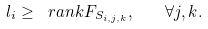Convert formula to latex. <formula><loc_0><loc_0><loc_500><loc_500>l _ { i } \geq \ r a n k F _ { S _ { i , j , k } } , \quad \forall j , k .</formula> 